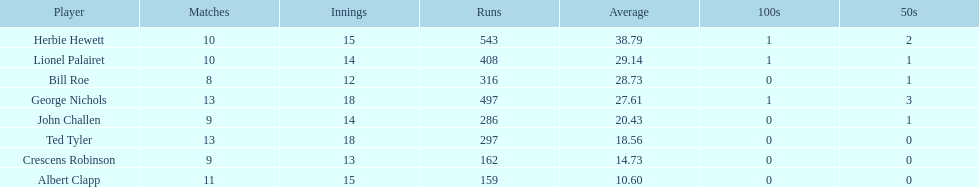Can you give me this table as a dict? {'header': ['Player', 'Matches', 'Innings', 'Runs', 'Average', '100s', '50s'], 'rows': [['Herbie Hewett', '10', '15', '543', '38.79', '1', '2'], ['Lionel Palairet', '10', '14', '408', '29.14', '1', '1'], ['Bill Roe', '8', '12', '316', '28.73', '0', '1'], ['George Nichols', '13', '18', '497', '27.61', '1', '3'], ['John Challen', '9', '14', '286', '20.43', '0', '1'], ['Ted Tyler', '13', '18', '297', '18.56', '0', '0'], ['Crescens Robinson', '9', '13', '162', '14.73', '0', '0'], ['Albert Clapp', '11', '15', '159', '10.60', '0', '0']]} What is the number of players who participated in over 10 matches? 3. 